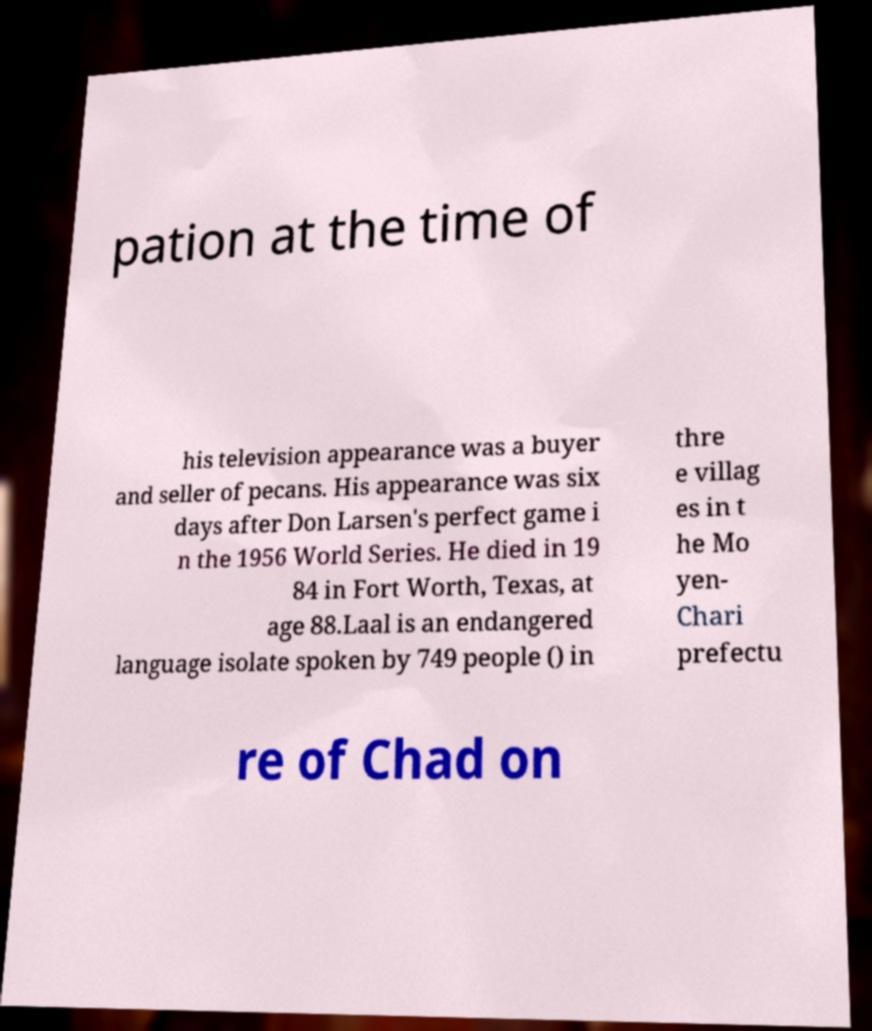Please read and relay the text visible in this image. What does it say? pation at the time of his television appearance was a buyer and seller of pecans. His appearance was six days after Don Larsen's perfect game i n the 1956 World Series. He died in 19 84 in Fort Worth, Texas, at age 88.Laal is an endangered language isolate spoken by 749 people () in thre e villag es in t he Mo yen- Chari prefectu re of Chad on 